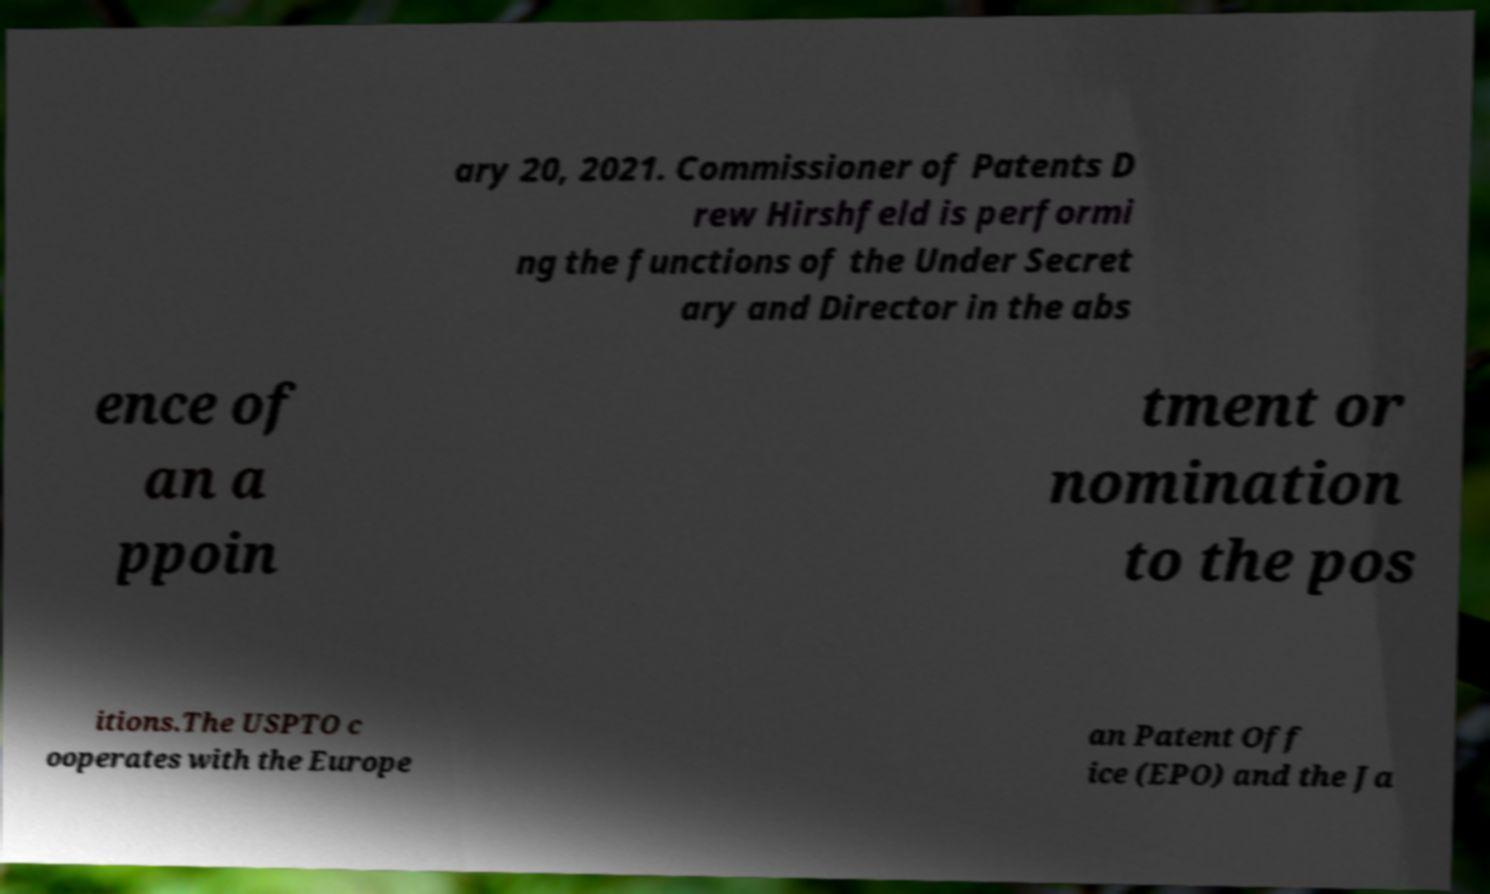What messages or text are displayed in this image? I need them in a readable, typed format. ary 20, 2021. Commissioner of Patents D rew Hirshfeld is performi ng the functions of the Under Secret ary and Director in the abs ence of an a ppoin tment or nomination to the pos itions.The USPTO c ooperates with the Europe an Patent Off ice (EPO) and the Ja 